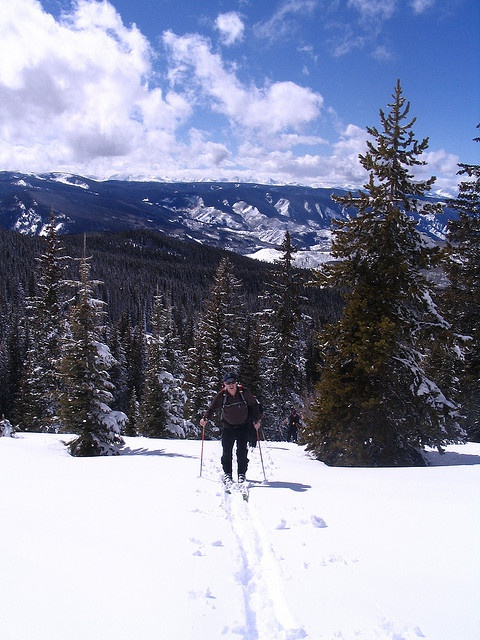Describe the objects in this image and their specific colors. I can see people in white, black, and gray tones and skis in white, gray, darkgray, and lavender tones in this image. 